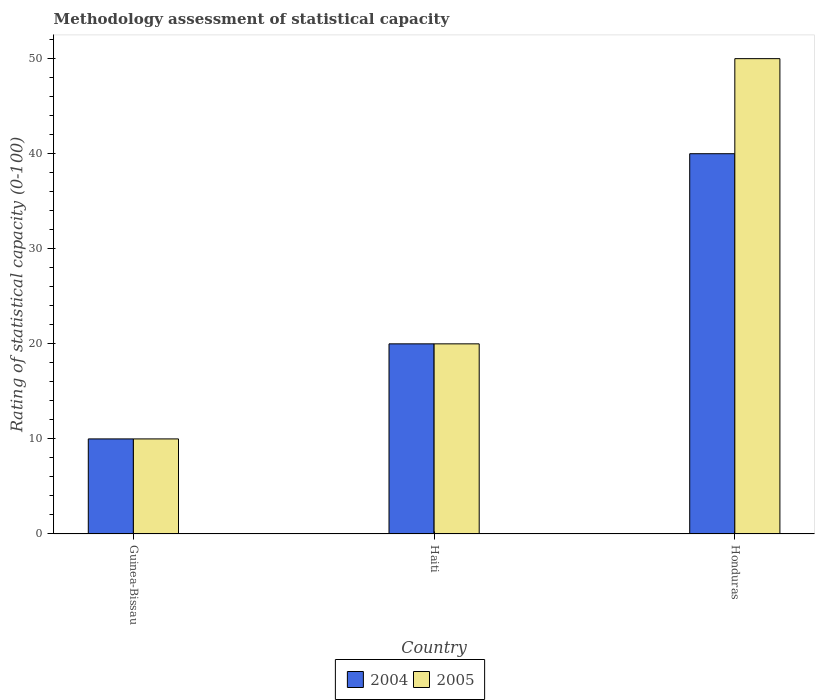How many different coloured bars are there?
Keep it short and to the point. 2. How many bars are there on the 1st tick from the left?
Provide a short and direct response. 2. What is the label of the 3rd group of bars from the left?
Provide a succinct answer. Honduras. What is the rating of statistical capacity in 2005 in Honduras?
Give a very brief answer. 50. In which country was the rating of statistical capacity in 2005 maximum?
Make the answer very short. Honduras. In which country was the rating of statistical capacity in 2004 minimum?
Provide a short and direct response. Guinea-Bissau. What is the difference between the rating of statistical capacity in 2004 in Guinea-Bissau and that in Haiti?
Offer a very short reply. -10. What is the average rating of statistical capacity in 2005 per country?
Your response must be concise. 26.67. In how many countries, is the rating of statistical capacity in 2005 greater than 4?
Offer a very short reply. 3. What is the ratio of the rating of statistical capacity in 2005 in Guinea-Bissau to that in Honduras?
Provide a succinct answer. 0.2. Is the rating of statistical capacity in 2005 in Guinea-Bissau less than that in Honduras?
Provide a succinct answer. Yes. Is the difference between the rating of statistical capacity in 2004 in Haiti and Honduras greater than the difference between the rating of statistical capacity in 2005 in Haiti and Honduras?
Make the answer very short. Yes. What is the difference between the highest and the lowest rating of statistical capacity in 2005?
Your response must be concise. 40. What does the 1st bar from the left in Honduras represents?
Provide a short and direct response. 2004. How many bars are there?
Keep it short and to the point. 6. Are all the bars in the graph horizontal?
Provide a succinct answer. No. How many countries are there in the graph?
Your answer should be compact. 3. How are the legend labels stacked?
Give a very brief answer. Horizontal. What is the title of the graph?
Offer a terse response. Methodology assessment of statistical capacity. Does "1978" appear as one of the legend labels in the graph?
Make the answer very short. No. What is the label or title of the Y-axis?
Provide a short and direct response. Rating of statistical capacity (0-100). What is the Rating of statistical capacity (0-100) in 2004 in Guinea-Bissau?
Make the answer very short. 10. Across all countries, what is the maximum Rating of statistical capacity (0-100) in 2005?
Offer a very short reply. 50. Across all countries, what is the minimum Rating of statistical capacity (0-100) of 2004?
Your response must be concise. 10. Across all countries, what is the minimum Rating of statistical capacity (0-100) in 2005?
Keep it short and to the point. 10. What is the difference between the Rating of statistical capacity (0-100) in 2004 in Guinea-Bissau and that in Honduras?
Make the answer very short. -30. What is the difference between the Rating of statistical capacity (0-100) in 2005 in Guinea-Bissau and that in Honduras?
Keep it short and to the point. -40. What is the difference between the Rating of statistical capacity (0-100) of 2005 in Haiti and that in Honduras?
Make the answer very short. -30. What is the difference between the Rating of statistical capacity (0-100) of 2004 in Haiti and the Rating of statistical capacity (0-100) of 2005 in Honduras?
Your answer should be very brief. -30. What is the average Rating of statistical capacity (0-100) of 2004 per country?
Provide a short and direct response. 23.33. What is the average Rating of statistical capacity (0-100) of 2005 per country?
Your response must be concise. 26.67. What is the difference between the Rating of statistical capacity (0-100) of 2004 and Rating of statistical capacity (0-100) of 2005 in Guinea-Bissau?
Keep it short and to the point. 0. What is the ratio of the Rating of statistical capacity (0-100) in 2004 in Guinea-Bissau to that in Haiti?
Keep it short and to the point. 0.5. What is the ratio of the Rating of statistical capacity (0-100) of 2005 in Guinea-Bissau to that in Haiti?
Keep it short and to the point. 0.5. What is the ratio of the Rating of statistical capacity (0-100) in 2004 in Guinea-Bissau to that in Honduras?
Your response must be concise. 0.25. What is the ratio of the Rating of statistical capacity (0-100) of 2004 in Haiti to that in Honduras?
Ensure brevity in your answer.  0.5. What is the ratio of the Rating of statistical capacity (0-100) of 2005 in Haiti to that in Honduras?
Make the answer very short. 0.4. What is the difference between the highest and the second highest Rating of statistical capacity (0-100) of 2005?
Your response must be concise. 30. 